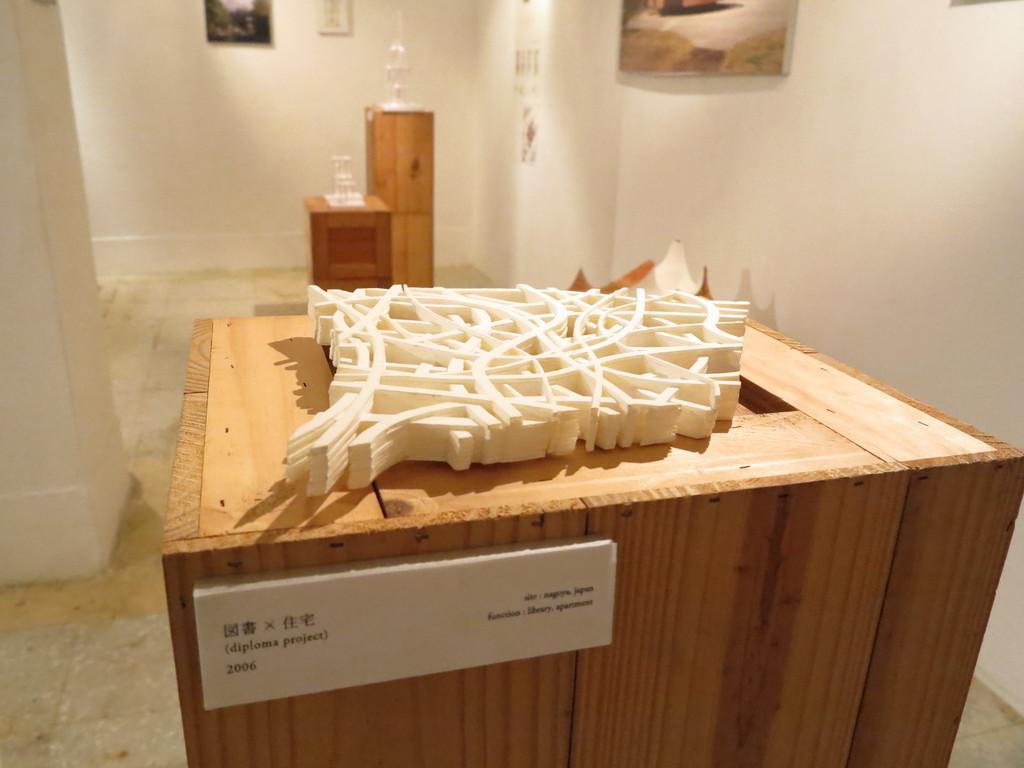Can you describe this image briefly? In this picture I can see there is a wooden table and there is a white color object placed on it. There is a board attached to the table and there is some information on it. In the backdrop there are two other wooden tables and there are few objects placed on it. On to right there is a wall with a photo frame and in the backdrop there is a photo frame. 